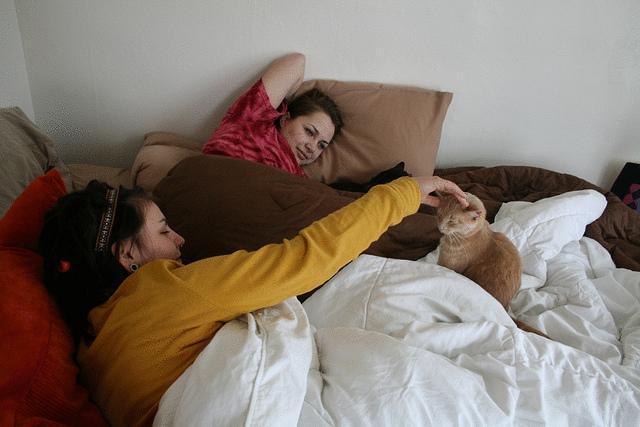How many people are in the bed?
Give a very brief answer. 2. How many people are there?
Give a very brief answer. 2. 